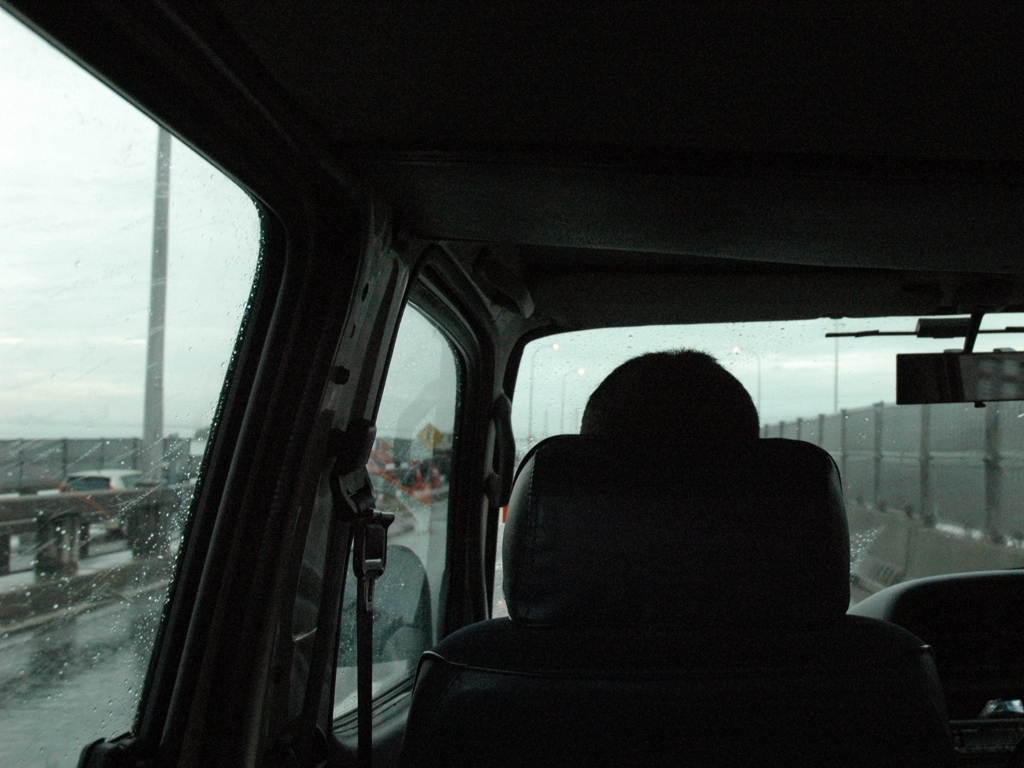Can you describe the setting captured in the image? The setting is inside a vehicle, seemingly on a road trip or commute during a rainy day. The overcast light and raindrops on the window overlay a scene of an obscured landscape and city structures, possibly indicating an urban environment. How does the weather affect the mood of the image? The rainy weather adds a layer of introspection and a slightly melancholic tone to the mood of the image. It could signify a literal and metaphorical journey, hinting at the passing of time and moments of solitude within the hustle of urban life. 